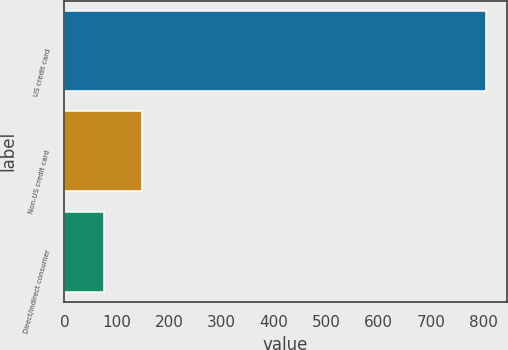Convert chart. <chart><loc_0><loc_0><loc_500><loc_500><bar_chart><fcel>US credit card<fcel>Non-US credit card<fcel>Direct/Indirect consumer<nl><fcel>804<fcel>148.8<fcel>76<nl></chart> 